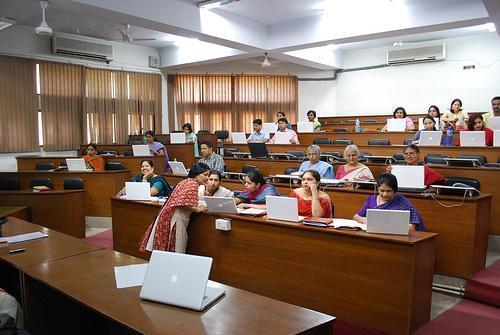Which country is this class most likely taught in?
Choose the right answer from the provided options to respond to the question.
Options: Mexico, saudi arabia, india, china. India. 